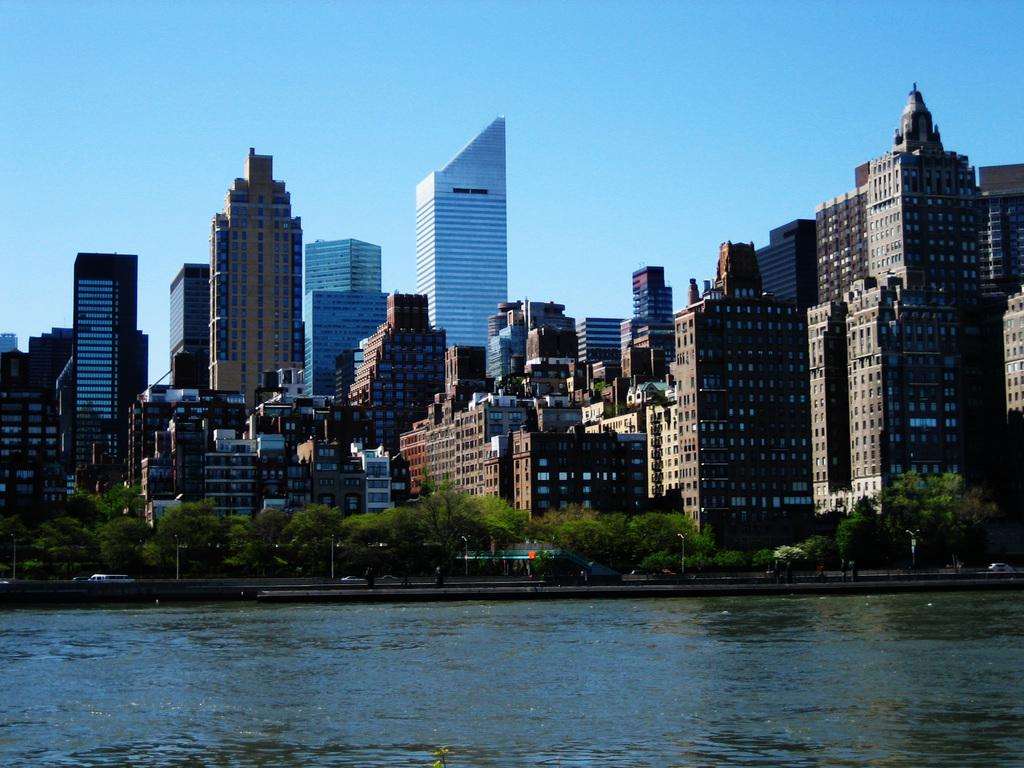What is the primary element present in the image? There is water in the image. What type of natural elements can be seen in the image? There are trees in the image. What type of man-made structures are visible in the image? There are buildings in the image. What type of transportation is visible in the image? Vehicles are visible on the road in the image. What type of tin can be seen in the image? There is no tin present in the image. What role does the fireman play in the image? There is no fireman present in the image. 